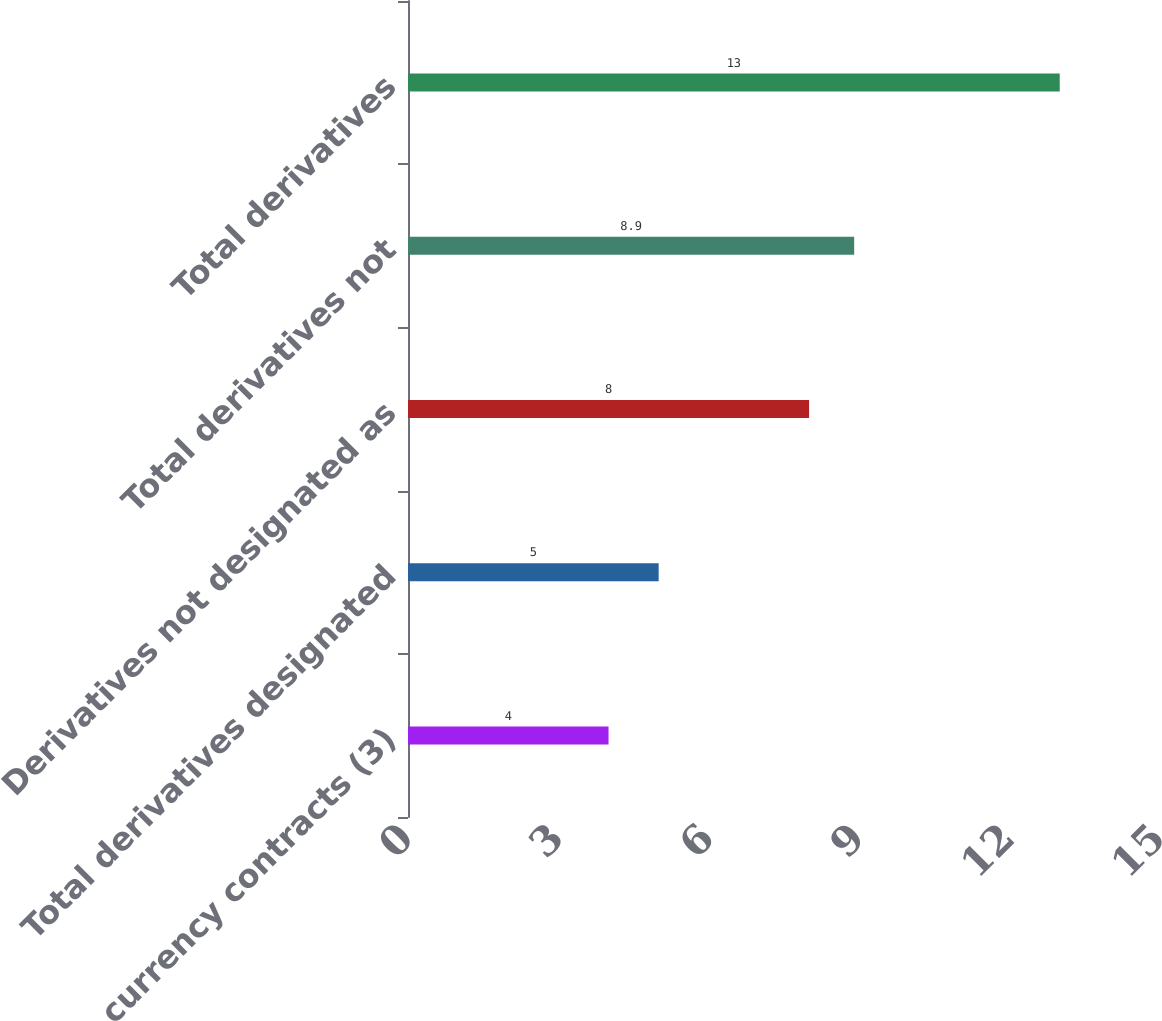Convert chart to OTSL. <chart><loc_0><loc_0><loc_500><loc_500><bar_chart><fcel>Foreign currency contracts (3)<fcel>Total derivatives designated<fcel>Derivatives not designated as<fcel>Total derivatives not<fcel>Total derivatives<nl><fcel>4<fcel>5<fcel>8<fcel>8.9<fcel>13<nl></chart> 